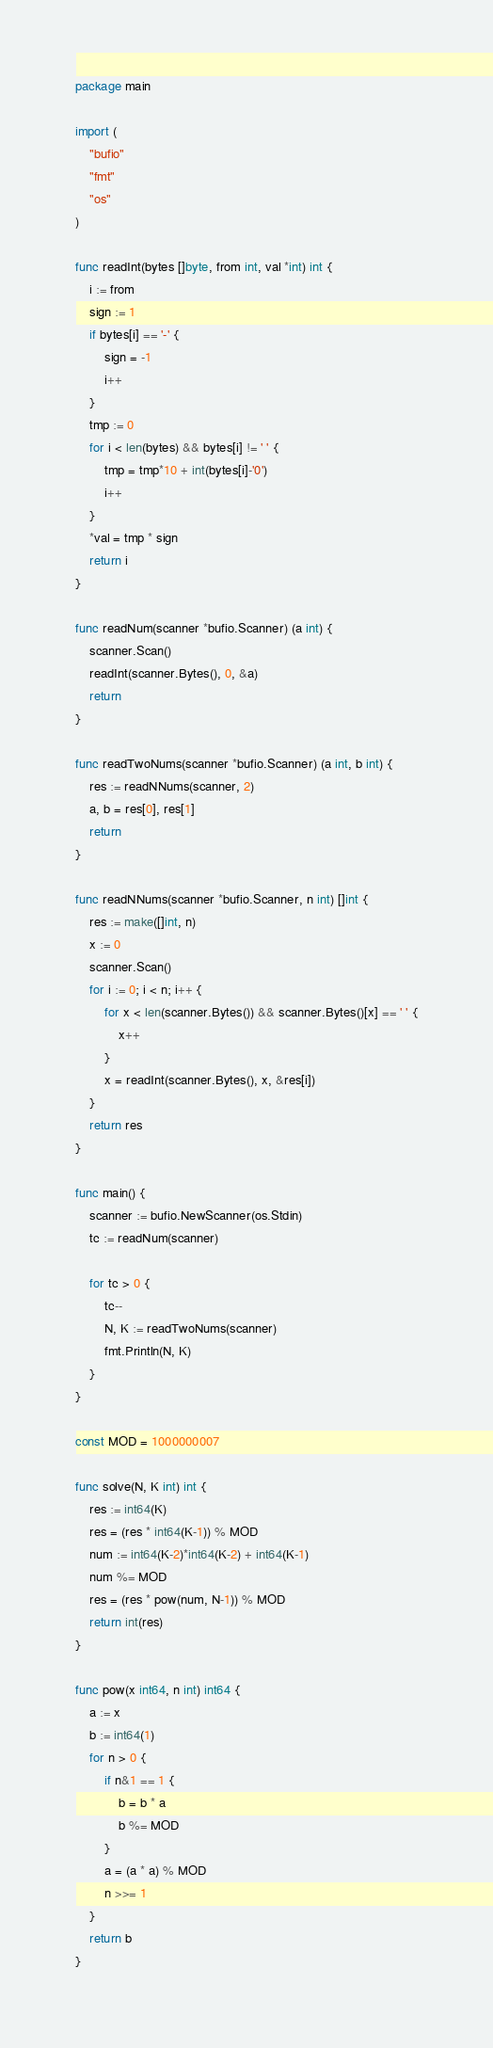<code> <loc_0><loc_0><loc_500><loc_500><_Go_>package main

import (
	"bufio"
	"fmt"
	"os"
)

func readInt(bytes []byte, from int, val *int) int {
	i := from
	sign := 1
	if bytes[i] == '-' {
		sign = -1
		i++
	}
	tmp := 0
	for i < len(bytes) && bytes[i] != ' ' {
		tmp = tmp*10 + int(bytes[i]-'0')
		i++
	}
	*val = tmp * sign
	return i
}

func readNum(scanner *bufio.Scanner) (a int) {
	scanner.Scan()
	readInt(scanner.Bytes(), 0, &a)
	return
}

func readTwoNums(scanner *bufio.Scanner) (a int, b int) {
	res := readNNums(scanner, 2)
	a, b = res[0], res[1]
	return
}

func readNNums(scanner *bufio.Scanner, n int) []int {
	res := make([]int, n)
	x := 0
	scanner.Scan()
	for i := 0; i < n; i++ {
		for x < len(scanner.Bytes()) && scanner.Bytes()[x] == ' ' {
			x++
		}
		x = readInt(scanner.Bytes(), x, &res[i])
	}
	return res
}

func main() {
	scanner := bufio.NewScanner(os.Stdin)
	tc := readNum(scanner)

	for tc > 0 {
		tc--
		N, K := readTwoNums(scanner)
		fmt.Println(N, K)
	}
}

const MOD = 1000000007

func solve(N, K int) int {
	res := int64(K)
	res = (res * int64(K-1)) % MOD
	num := int64(K-2)*int64(K-2) + int64(K-1)
	num %= MOD
	res = (res * pow(num, N-1)) % MOD
	return int(res)
}

func pow(x int64, n int) int64 {
	a := x
	b := int64(1)
	for n > 0 {
		if n&1 == 1 {
			b = b * a
			b %= MOD
		}
		a = (a * a) % MOD
		n >>= 1
	}
	return b
}
</code> 